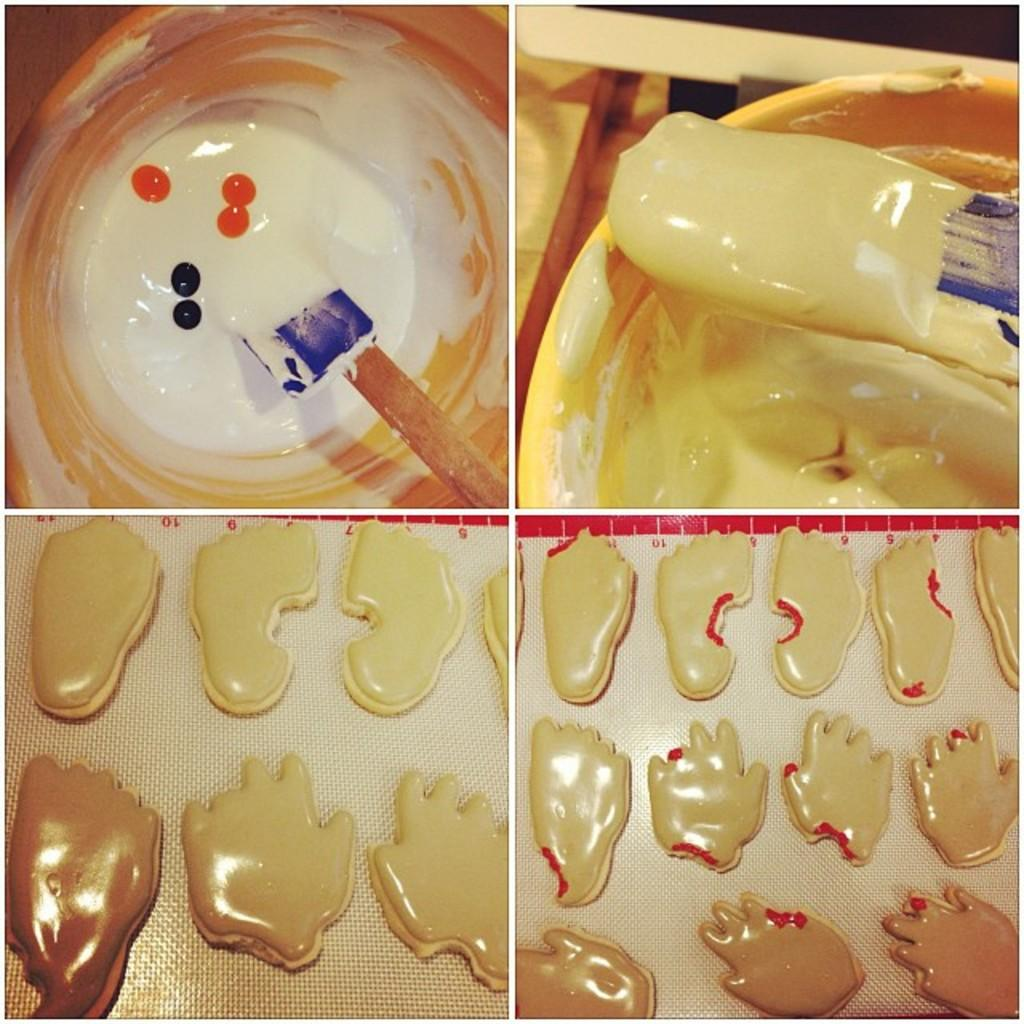What tool is visible in the image? There is a paint brush in the image. Where is the paint brush located? The paint brush is in a bucket. What is in the bucket with the paint brush? The bucket contains paint. What other objects can be seen in the image? There are different moulds in the image. How is the image presented? The image is a photo grid. What month is it in the image? The month is not mentioned or depicted in the image. How much heat is being generated by the paint brush in the image? The paint brush is not generating heat in the image; it is simply resting in the bucket of paint. 